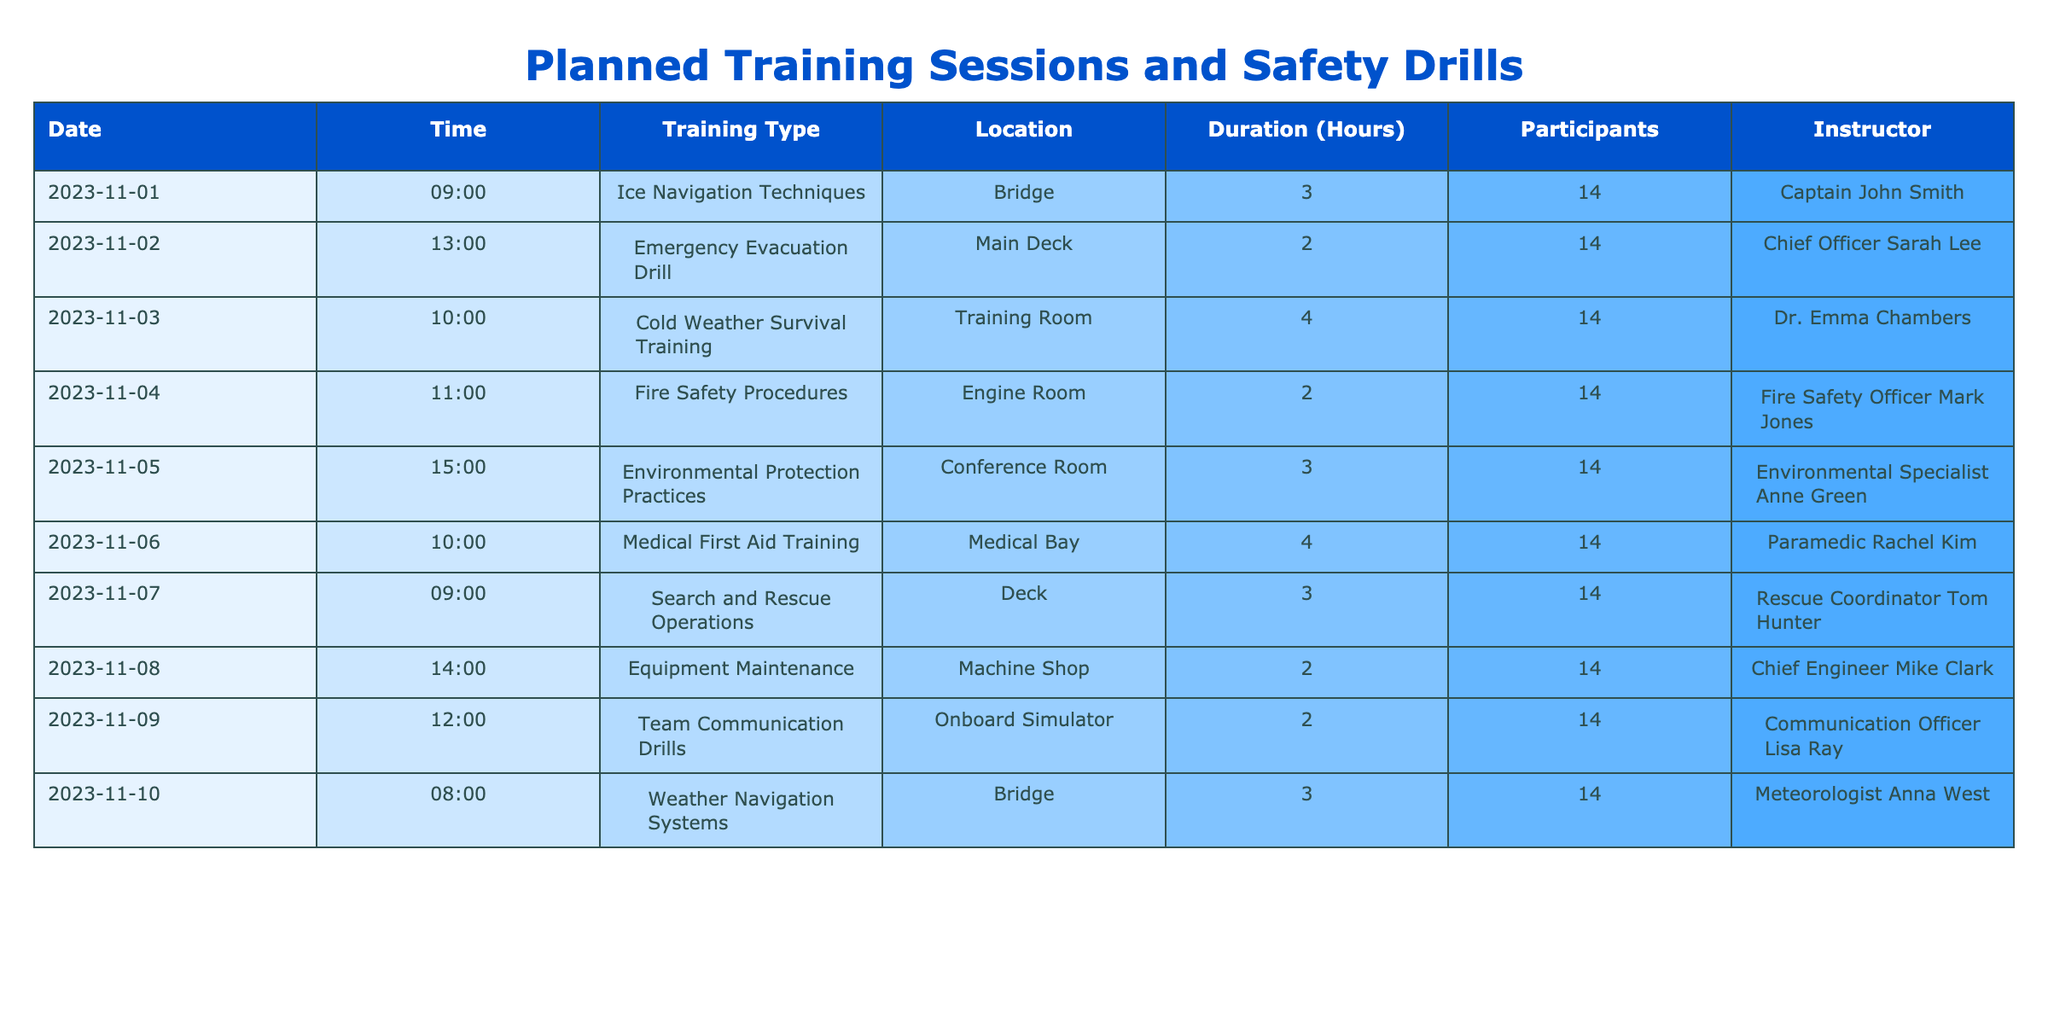What is the date of the Emergency Evacuation Drill? The Emergency Evacuation Drill is listed in the table under the "Training Type" column. It is scheduled for the date mentioned in the same row, which is November 2, 2023.
Answer: November 2, 2023 Who is the instructor for Medical First Aid Training? To find the instructor for Medical First Aid Training, look at the row where "Medical First Aid Training" is specified in the "Training Type" column. In that row, the "Instructor" column indicates that Rachel Kim is the instructor.
Answer: Rachel Kim What is the total duration of the training sessions planned for November 1st to November 5th? To find the total duration, review the "Duration (Hours)" column for the sessions scheduled from November 1st to November 5th: 3 (Ice Navigation Techniques) + 2 (Emergency Evacuation Drill) + 4 (Cold Weather Survival Training) + 2 (Fire Safety Procedures) + 3 (Environmental Protection Practices) = 14 hours.
Answer: 14 hours Is there a training session scheduled in the Machine Shop? Check the "Location" column for any mention of the Machine Shop. The table shows that there is a training session titled "Equipment Maintenance" scheduled in the Machine Shop on November 8th. Hence, the answer is true.
Answer: Yes Which training session has the longest duration, and what is its duration? To determine the longest training session, compare the durations listed in the "Duration (Hours)" column. The Cold Weather Survival Training on November 3rd has a duration of 4 hours, which is the maximum when compared with other sessions.
Answer: Cold Weather Survival Training, 4 hours What is the average number of participants across all training sessions? All sessions listed have the same number of participants, which is 14. Consequently, the average is simply that same number since there is consistency across all sessions: (14 + 14 + 14 + 14 + 14 + 14 + 14 + 14 + 14 + 14) / 10 = 14.
Answer: 14 On what date and time is the Weather Navigation Systems training held? The "Training Type" for Weather Navigation Systems is presented with its corresponding details below it. Upon reviewing the associated row, the date is November 10 and the time is 8:00 AM.
Answer: November 10, 8:00 AM How many different training types are scheduled for the week of November 1st to November 7th? Count the unique training types listed in the session dates between November 1st and November 7th. The sessions are: Ice Navigation Techniques, Emergency Evacuation Drill, Cold Weather Survival Training, Fire Safety Procedures, and Search and Rescue Operations, making a total of 5 different types.
Answer: 5 different types 